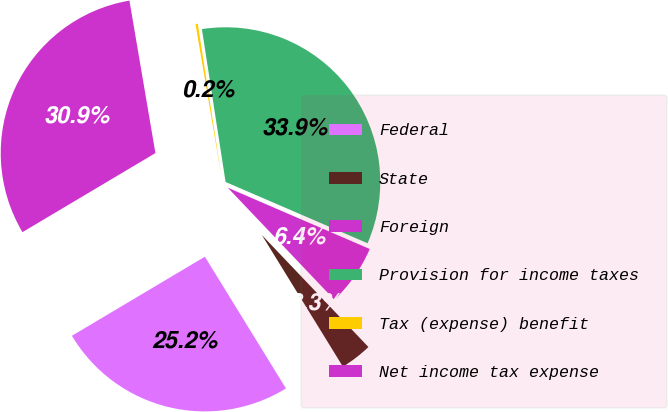<chart> <loc_0><loc_0><loc_500><loc_500><pie_chart><fcel>Federal<fcel>State<fcel>Foreign<fcel>Provision for income taxes<fcel>Tax (expense) benefit<fcel>Net income tax expense<nl><fcel>25.24%<fcel>3.32%<fcel>6.41%<fcel>33.93%<fcel>0.24%<fcel>30.85%<nl></chart> 